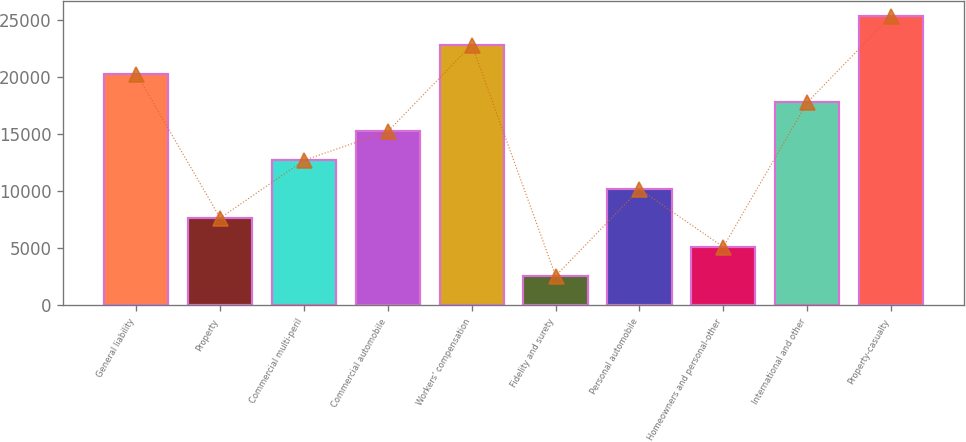Convert chart. <chart><loc_0><loc_0><loc_500><loc_500><bar_chart><fcel>General liability<fcel>Property<fcel>Commercial multi-peril<fcel>Commercial automobile<fcel>Workers' compensation<fcel>Fidelity and surety<fcel>Personal automobile<fcel>Homeowners and personal-other<fcel>International and other<fcel>Property-casualty<nl><fcel>20329.8<fcel>7661.8<fcel>12729<fcel>15262.6<fcel>22863.4<fcel>2594.6<fcel>10195.4<fcel>5128.2<fcel>17796.2<fcel>25397<nl></chart> 